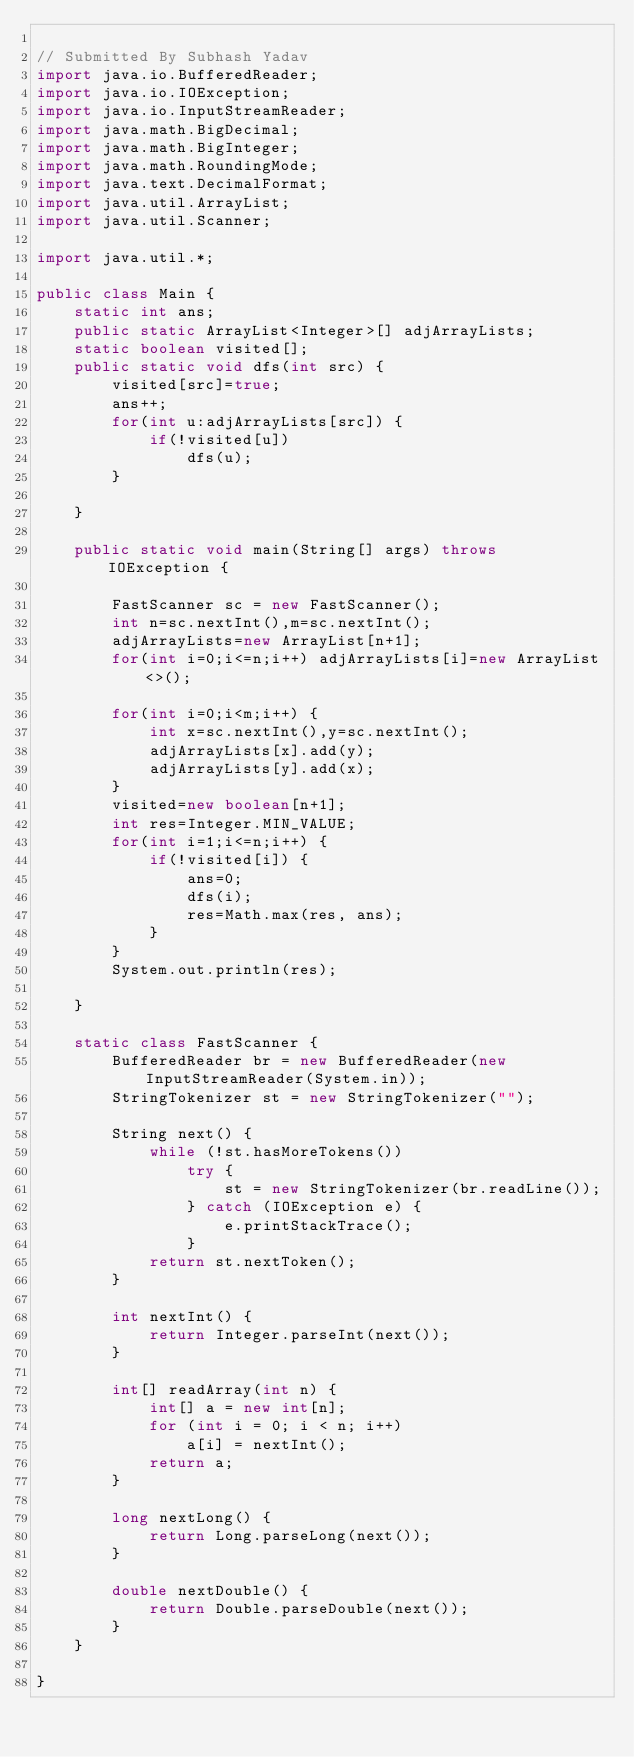<code> <loc_0><loc_0><loc_500><loc_500><_Java_>
// Submitted By Subhash Yadav
import java.io.BufferedReader;
import java.io.IOException;
import java.io.InputStreamReader;
import java.math.BigDecimal;
import java.math.BigInteger;
import java.math.RoundingMode;
import java.text.DecimalFormat;
import java.util.ArrayList;
import java.util.Scanner;

import java.util.*;

public class Main {
	static int ans;
	public static ArrayList<Integer>[] adjArrayLists;
	static boolean visited[];
	public static void dfs(int src) {
		visited[src]=true;
		ans++;
		for(int u:adjArrayLists[src]) {
			if(!visited[u])
				dfs(u);
		}
		
	}

	public static void main(String[] args) throws IOException {

		FastScanner sc = new FastScanner();
		int n=sc.nextInt(),m=sc.nextInt();
		adjArrayLists=new ArrayList[n+1];
		for(int i=0;i<=n;i++) adjArrayLists[i]=new ArrayList<>();
				
		for(int i=0;i<m;i++) {
			int x=sc.nextInt(),y=sc.nextInt();
			adjArrayLists[x].add(y);
			adjArrayLists[y].add(x);
		}
		visited=new boolean[n+1];
		int res=Integer.MIN_VALUE;
		for(int i=1;i<=n;i++) {
			if(!visited[i]) {
				ans=0;
				dfs(i);
				res=Math.max(res, ans);
			}
		}
		System.out.println(res);

	}

	static class FastScanner {
		BufferedReader br = new BufferedReader(new InputStreamReader(System.in));
		StringTokenizer st = new StringTokenizer("");

		String next() {
			while (!st.hasMoreTokens())
				try {
					st = new StringTokenizer(br.readLine());
				} catch (IOException e) {
					e.printStackTrace();
				}
			return st.nextToken();
		}

		int nextInt() {
			return Integer.parseInt(next());
		}

		int[] readArray(int n) {
			int[] a = new int[n];
			for (int i = 0; i < n; i++)
				a[i] = nextInt();
			return a;
		}

		long nextLong() {
			return Long.parseLong(next());
		}

		double nextDouble() {
			return Double.parseDouble(next());
		}
	}

}</code> 